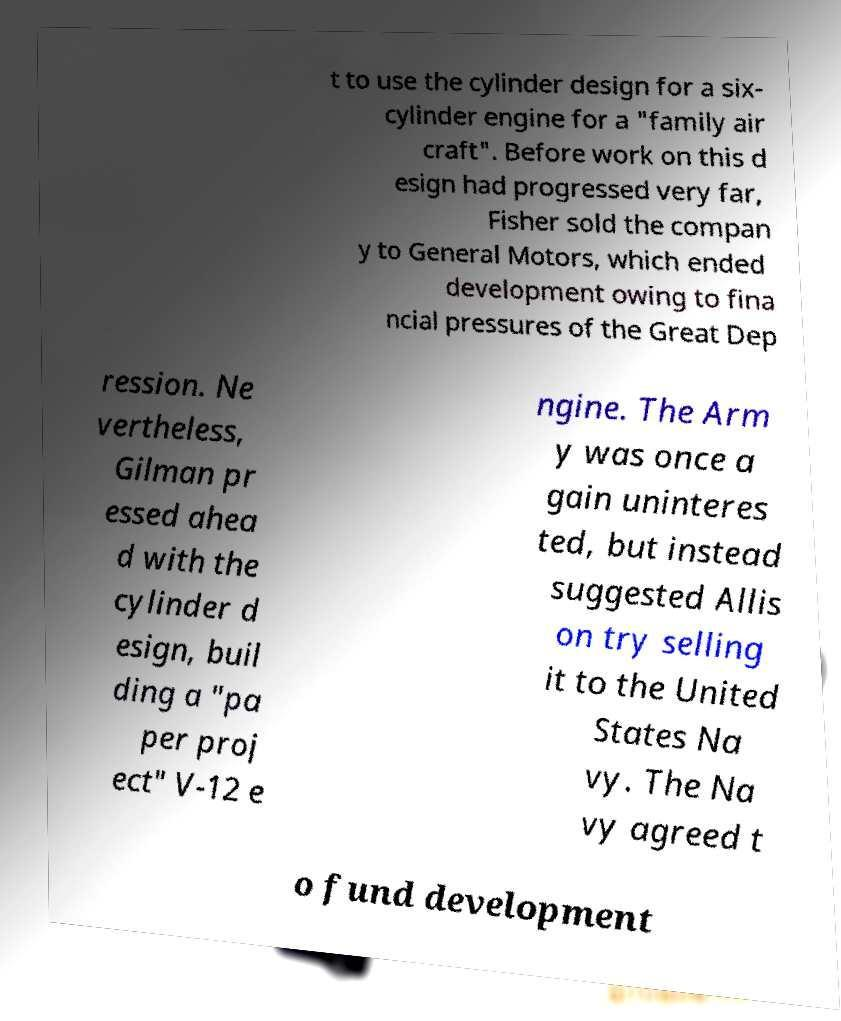What messages or text are displayed in this image? I need them in a readable, typed format. t to use the cylinder design for a six- cylinder engine for a "family air craft". Before work on this d esign had progressed very far, Fisher sold the compan y to General Motors, which ended development owing to fina ncial pressures of the Great Dep ression. Ne vertheless, Gilman pr essed ahea d with the cylinder d esign, buil ding a "pa per proj ect" V-12 e ngine. The Arm y was once a gain uninteres ted, but instead suggested Allis on try selling it to the United States Na vy. The Na vy agreed t o fund development 